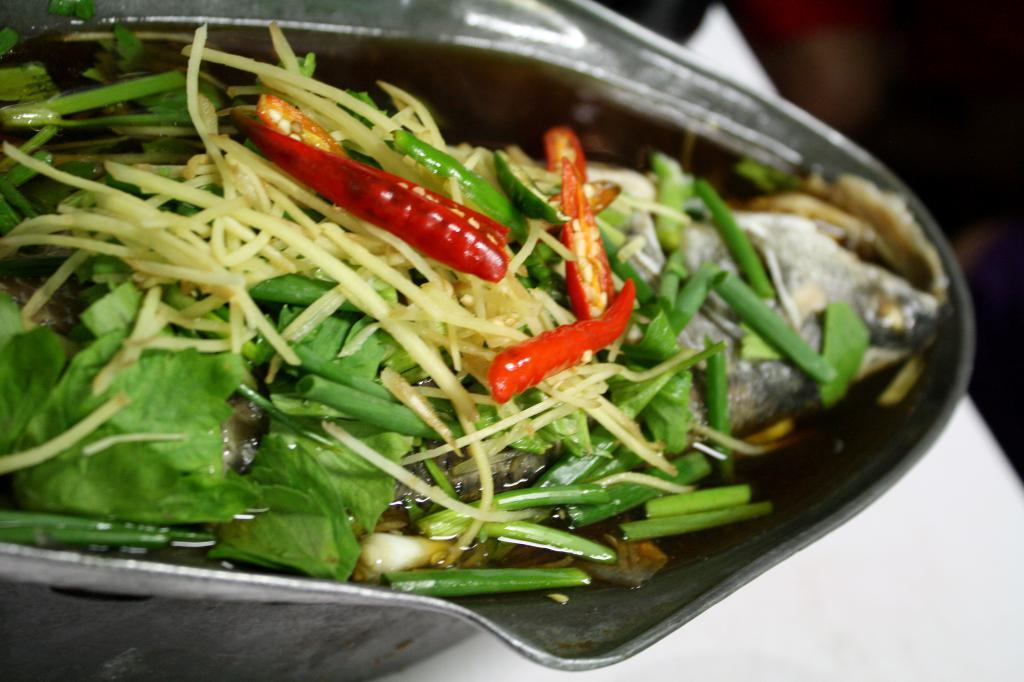What is in the bowl that is visible in the image? There are chopped vegetables in a bowl. Where is the bowl located in the image? The bowl is placed on a surface. What type of lamp is present in the image? There is no lamp present in the image. What kind of house can be seen in the background of the image? There is no house visible in the image; it only shows a bowl of chopped vegetables on a surface. 